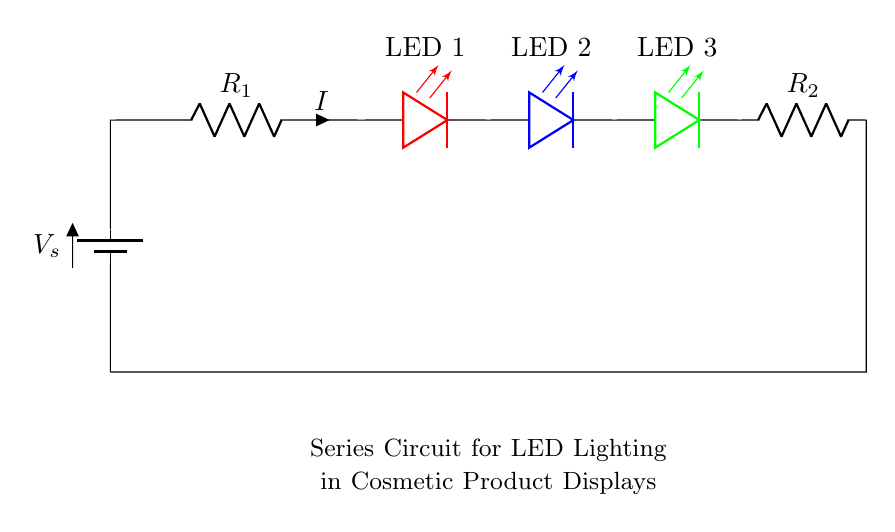What is the voltage supply in this circuit? The voltage supply is represented by the battery symbol in the circuit diagram, labeled as \(V_s\). This indicates the source of electrical energy for the circuit.
Answer: Vs How many resistors are present in the circuit? The circuit diagram shows two resistors, indicated by the symbols \(R_1\) and \(R_2\). They are clearly labeled in the diagram.
Answer: 2 What is the current flowing through the LEDs? The current flowing through the LEDs is labeled as \(I\) in the diagram. Since the components are in series, the same current flows through all of them.
Answer: I Which colors are the LEDs in this circuit? The circuit contains three LEDs, specifically colored red, blue, and green, as indicated next to each LED in the diagram.
Answer: Red, blue, green What type of circuit is represented here? The circuit diagram shows a series configuration, where components are connected end-to-end, so the same current flows through all components.
Answer: Series Why do the LEDs share the same current in this circuit? In a series circuit, all components are connected in a single path, which results in the same current passing through each component, including the LEDs. This is due to the nature of series configurations, where current must flow through each component sequentially.
Answer: Same current 